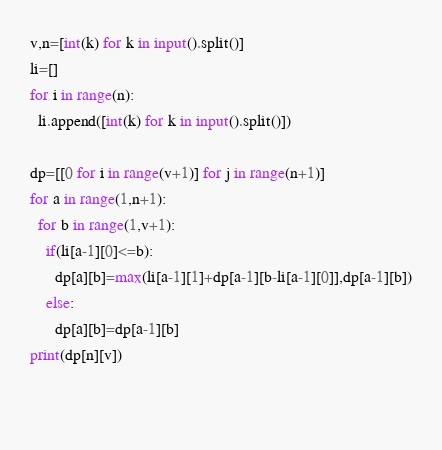Convert code to text. <code><loc_0><loc_0><loc_500><loc_500><_Python_>v,n=[int(k) for k in input().split()]
li=[]
for i in range(n):
  li.append([int(k) for k in input().split()])
  
dp=[[0 for i in range(v+1)] for j in range(n+1)]
for a in range(1,n+1):
  for b in range(1,v+1):
    if(li[a-1][0]<=b):
      dp[a][b]=max(li[a-1][1]+dp[a-1][b-li[a-1][0]],dp[a-1][b])
    else:
      dp[a][b]=dp[a-1][b]
print(dp[n][v])      
      
  </code> 